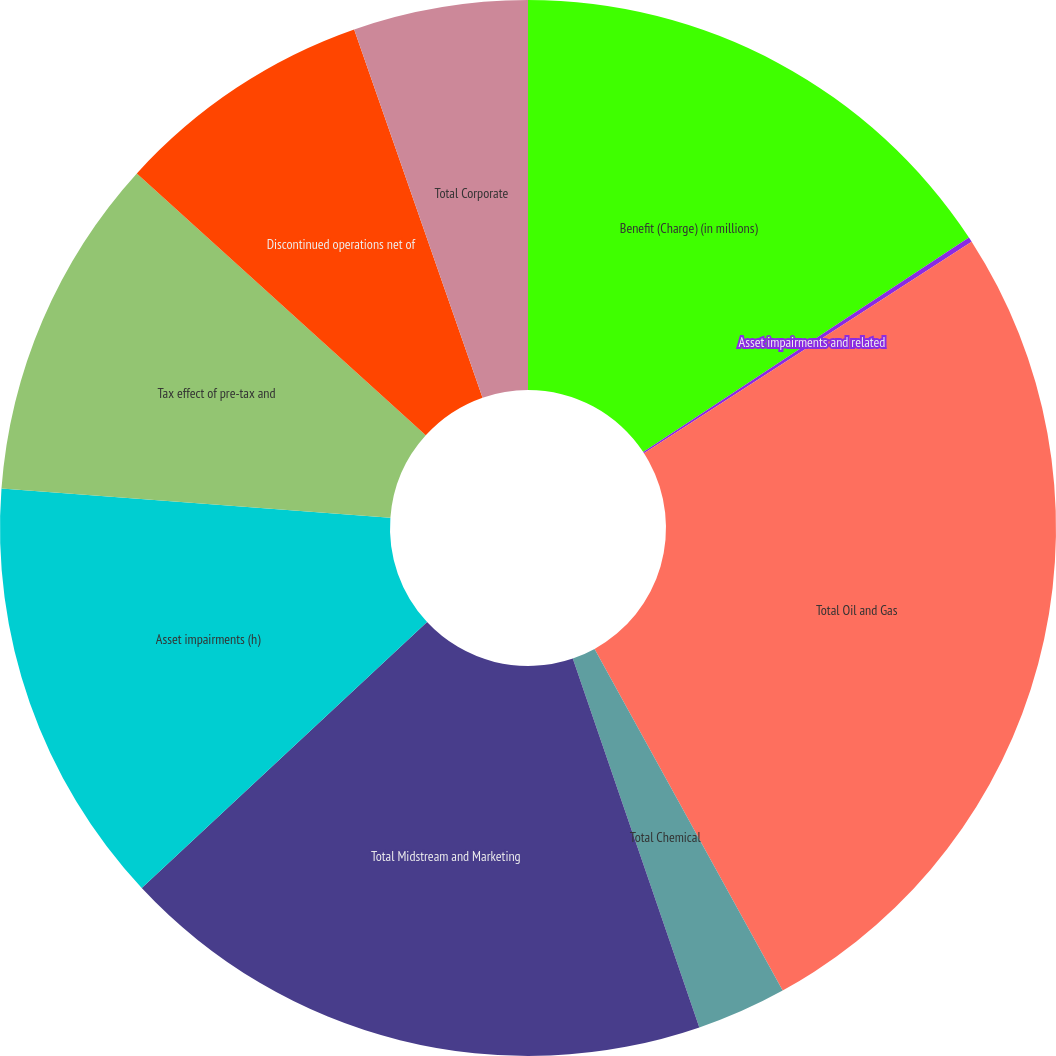Convert chart to OTSL. <chart><loc_0><loc_0><loc_500><loc_500><pie_chart><fcel>Benefit (Charge) (in millions)<fcel>Asset impairments and related<fcel>Total Oil and Gas<fcel>Total Chemical<fcel>Total Midstream and Marketing<fcel>Asset impairments (h)<fcel>Tax effect of pre-tax and<fcel>Discontinued operations net of<fcel>Total Corporate<nl><fcel>15.73%<fcel>0.15%<fcel>26.11%<fcel>2.75%<fcel>18.32%<fcel>13.13%<fcel>10.53%<fcel>7.94%<fcel>5.34%<nl></chart> 